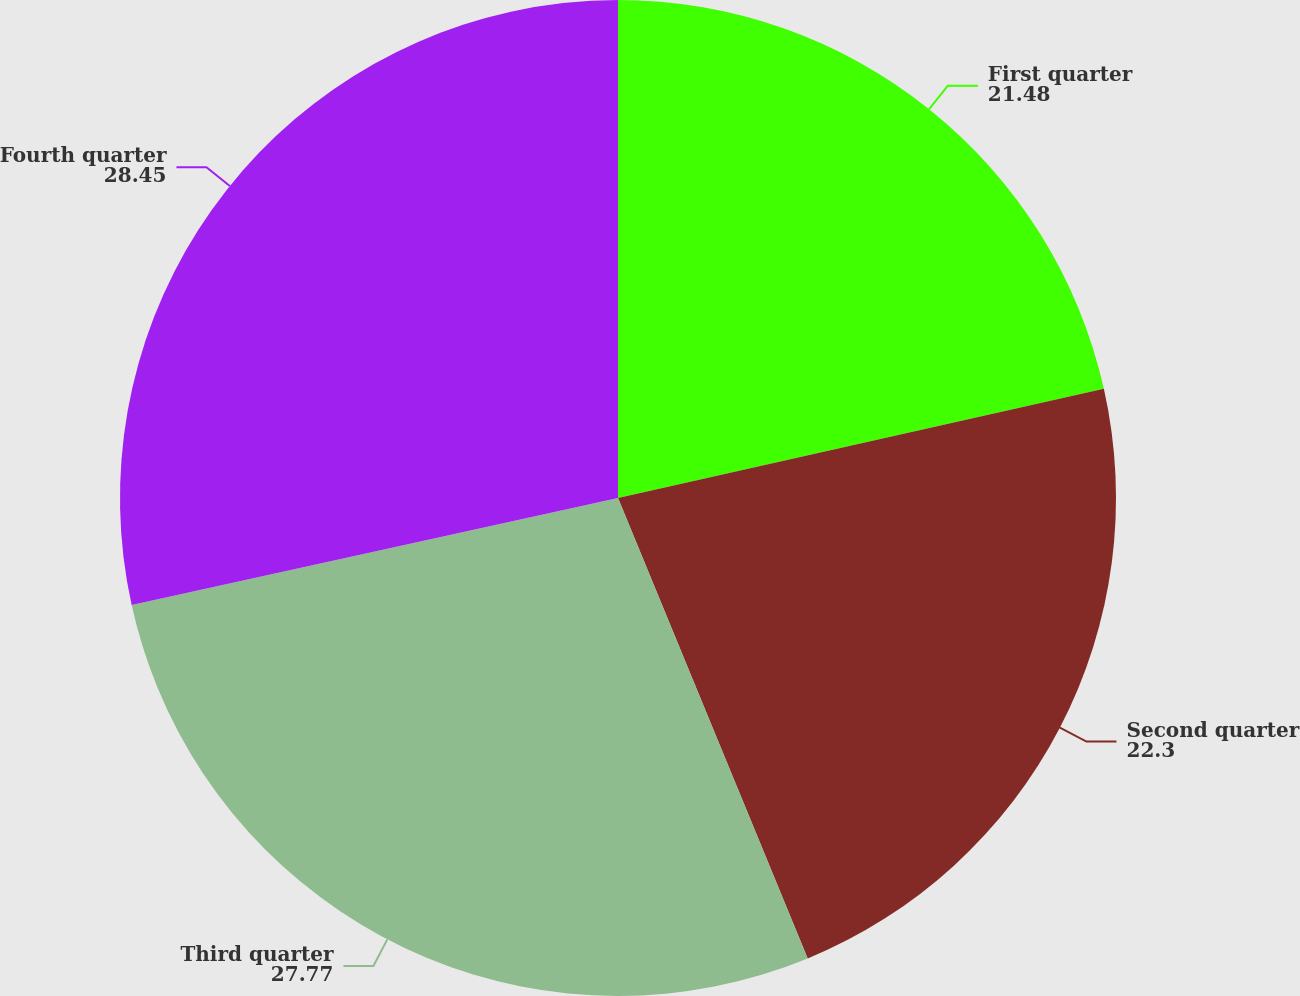Convert chart. <chart><loc_0><loc_0><loc_500><loc_500><pie_chart><fcel>First quarter<fcel>Second quarter<fcel>Third quarter<fcel>Fourth quarter<nl><fcel>21.48%<fcel>22.3%<fcel>27.77%<fcel>28.45%<nl></chart> 